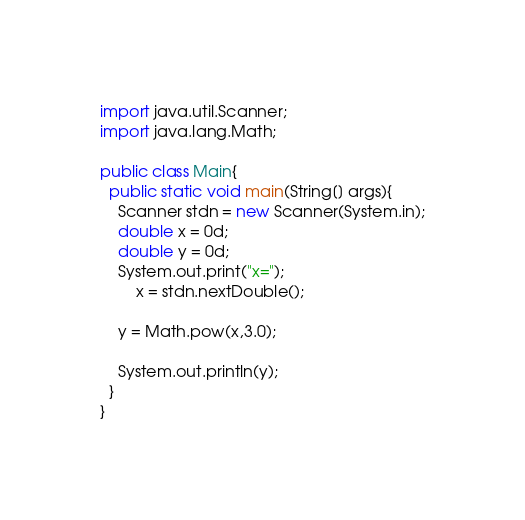<code> <loc_0><loc_0><loc_500><loc_500><_Java_>import java.util.Scanner;
import java.lang.Math;

public class Main{
  public static void main(String[] args){
  	Scanner stdn = new Scanner(System.in);
	double x = 0d;
	double y = 0d;
  	System.out.print("x=");
  		x = stdn.nextDouble();
  	
  	y = Math.pow(x,3.0);
  	
    System.out.println(y);
  }
}</code> 